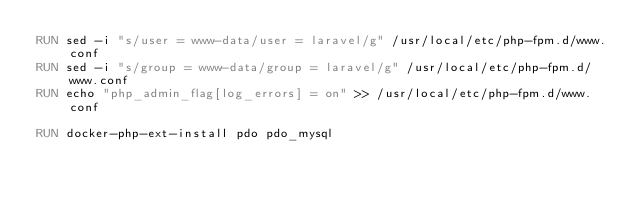Convert code to text. <code><loc_0><loc_0><loc_500><loc_500><_Dockerfile_>RUN sed -i "s/user = www-data/user = laravel/g" /usr/local/etc/php-fpm.d/www.conf
RUN sed -i "s/group = www-data/group = laravel/g" /usr/local/etc/php-fpm.d/www.conf
RUN echo "php_admin_flag[log_errors] = on" >> /usr/local/etc/php-fpm.d/www.conf

RUN docker-php-ext-install pdo pdo_mysql
</code> 